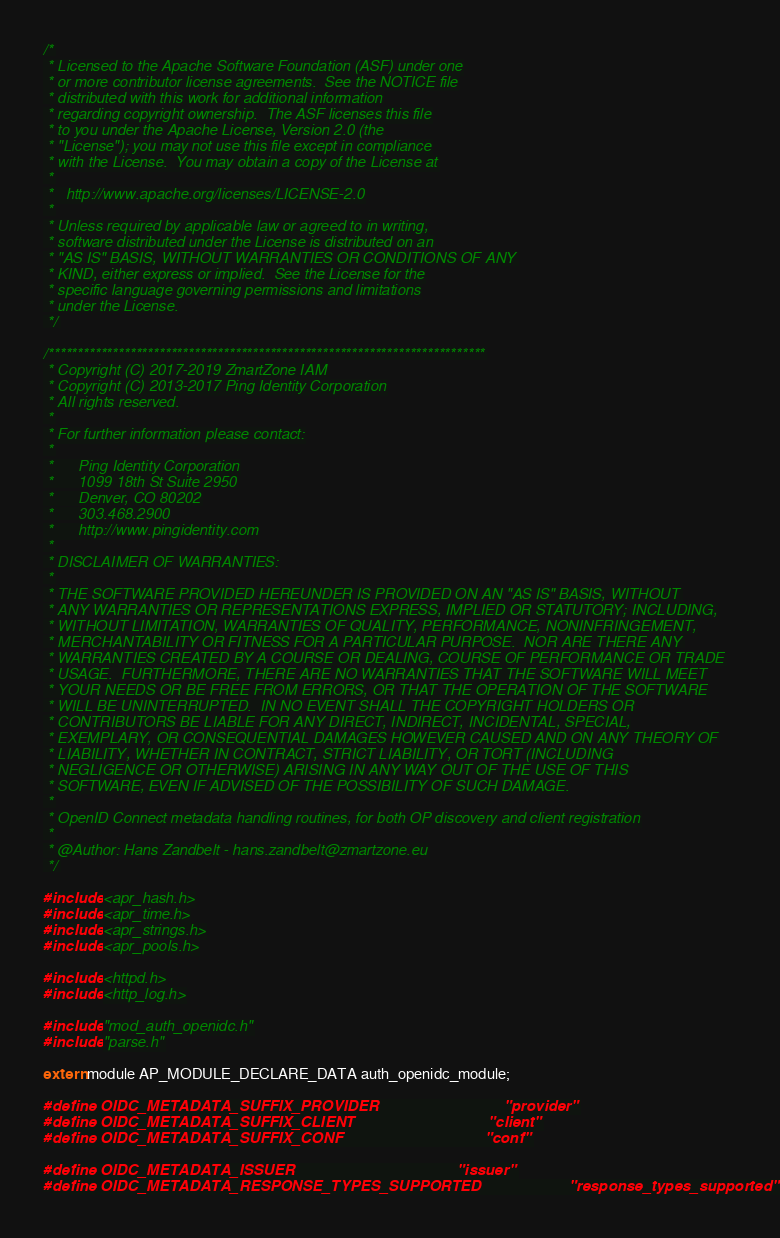<code> <loc_0><loc_0><loc_500><loc_500><_C_>/*
 * Licensed to the Apache Software Foundation (ASF) under one
 * or more contributor license agreements.  See the NOTICE file
 * distributed with this work for additional information
 * regarding copyright ownership.  The ASF licenses this file
 * to you under the Apache License, Version 2.0 (the
 * "License"); you may not use this file except in compliance
 * with the License.  You may obtain a copy of the License at
 *
 *   http://www.apache.org/licenses/LICENSE-2.0
 *
 * Unless required by applicable law or agreed to in writing,
 * software distributed under the License is distributed on an
 * "AS IS" BASIS, WITHOUT WARRANTIES OR CONDITIONS OF ANY
 * KIND, either express or implied.  See the License for the
 * specific language governing permissions and limitations
 * under the License.
 */

/***************************************************************************
 * Copyright (C) 2017-2019 ZmartZone IAM
 * Copyright (C) 2013-2017 Ping Identity Corporation
 * All rights reserved.
 *
 * For further information please contact:
 *
 *      Ping Identity Corporation
 *      1099 18th St Suite 2950
 *      Denver, CO 80202
 *      303.468.2900
 *      http://www.pingidentity.com
 *
 * DISCLAIMER OF WARRANTIES:
 *
 * THE SOFTWARE PROVIDED HEREUNDER IS PROVIDED ON AN "AS IS" BASIS, WITHOUT
 * ANY WARRANTIES OR REPRESENTATIONS EXPRESS, IMPLIED OR STATUTORY; INCLUDING,
 * WITHOUT LIMITATION, WARRANTIES OF QUALITY, PERFORMANCE, NONINFRINGEMENT,
 * MERCHANTABILITY OR FITNESS FOR A PARTICULAR PURPOSE.  NOR ARE THERE ANY
 * WARRANTIES CREATED BY A COURSE OR DEALING, COURSE OF PERFORMANCE OR TRADE
 * USAGE.  FURTHERMORE, THERE ARE NO WARRANTIES THAT THE SOFTWARE WILL MEET
 * YOUR NEEDS OR BE FREE FROM ERRORS, OR THAT THE OPERATION OF THE SOFTWARE
 * WILL BE UNINTERRUPTED.  IN NO EVENT SHALL THE COPYRIGHT HOLDERS OR
 * CONTRIBUTORS BE LIABLE FOR ANY DIRECT, INDIRECT, INCIDENTAL, SPECIAL,
 * EXEMPLARY, OR CONSEQUENTIAL DAMAGES HOWEVER CAUSED AND ON ANY THEORY OF
 * LIABILITY, WHETHER IN CONTRACT, STRICT LIABILITY, OR TORT (INCLUDING
 * NEGLIGENCE OR OTHERWISE) ARISING IN ANY WAY OUT OF THE USE OF THIS
 * SOFTWARE, EVEN IF ADVISED OF THE POSSIBILITY OF SUCH DAMAGE.
 *
 * OpenID Connect metadata handling routines, for both OP discovery and client registration
 *
 * @Author: Hans Zandbelt - hans.zandbelt@zmartzone.eu
 */

#include <apr_hash.h>
#include <apr_time.h>
#include <apr_strings.h>
#include <apr_pools.h>

#include <httpd.h>
#include <http_log.h>

#include "mod_auth_openidc.h"
#include "parse.h"

extern module AP_MODULE_DECLARE_DATA auth_openidc_module;

#define OIDC_METADATA_SUFFIX_PROVIDER                              "provider"
#define OIDC_METADATA_SUFFIX_CLIENT                                "client"
#define OIDC_METADATA_SUFFIX_CONF                                  "conf"

#define OIDC_METADATA_ISSUER                                       "issuer"
#define OIDC_METADATA_RESPONSE_TYPES_SUPPORTED                     "response_types_supported"</code> 